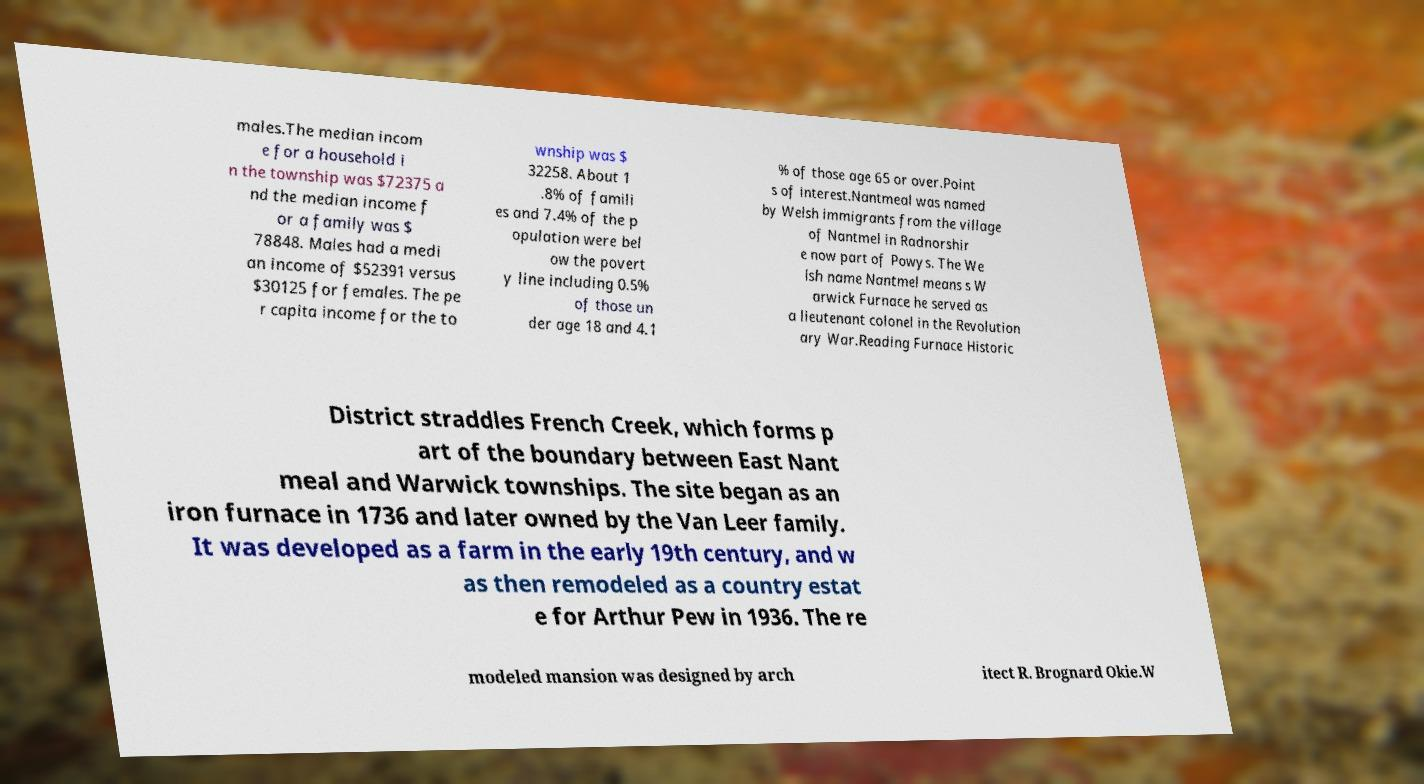Please identify and transcribe the text found in this image. males.The median incom e for a household i n the township was $72375 a nd the median income f or a family was $ 78848. Males had a medi an income of $52391 versus $30125 for females. The pe r capita income for the to wnship was $ 32258. About 1 .8% of famili es and 7.4% of the p opulation were bel ow the povert y line including 0.5% of those un der age 18 and 4.1 % of those age 65 or over.Point s of interest.Nantmeal was named by Welsh immigrants from the village of Nantmel in Radnorshir e now part of Powys. The We lsh name Nantmel means s W arwick Furnace he served as a lieutenant colonel in the Revolution ary War.Reading Furnace Historic District straddles French Creek, which forms p art of the boundary between East Nant meal and Warwick townships. The site began as an iron furnace in 1736 and later owned by the Van Leer family. It was developed as a farm in the early 19th century, and w as then remodeled as a country estat e for Arthur Pew in 1936. The re modeled mansion was designed by arch itect R. Brognard Okie.W 